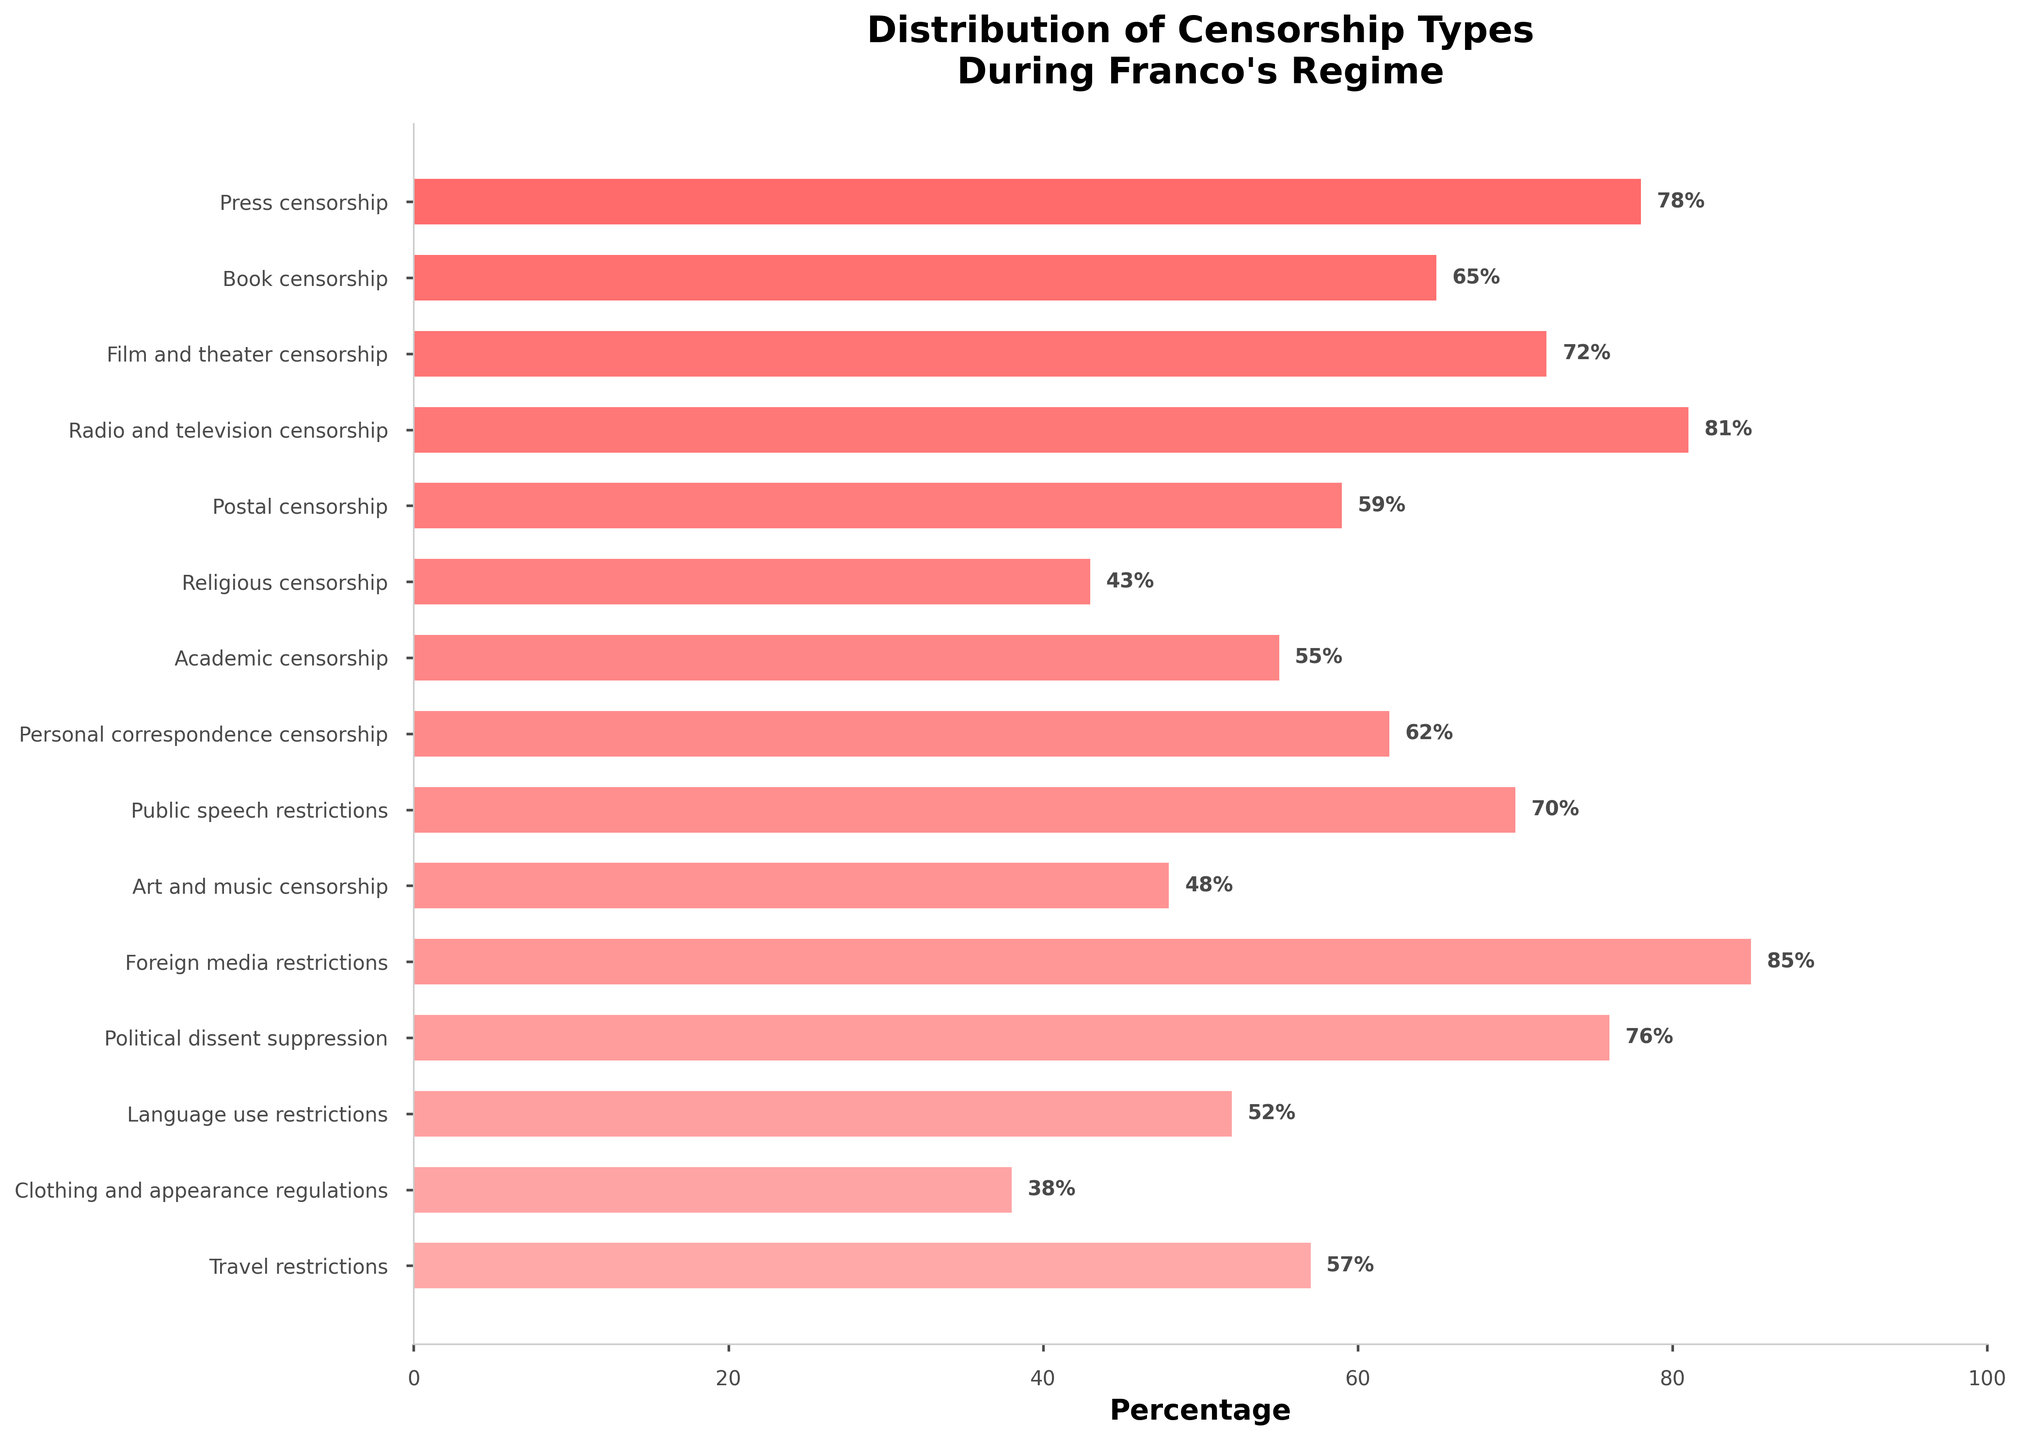Which type of censorship experienced by Spanish citizens during Franco's regime had the highest percentage? The highest percentage corresponds to foreign media restrictions, which had 85%.
Answer: Foreign media restrictions Which type of censorship had the smallest percentage? Clothing and appearance regulations had the lowest percentage at 38%.
Answer: Clothing and appearance regulations How does the percentage of press censorship compare to that of book censorship? Press censorship is 78%, which is higher than book censorship's 65%.
Answer: Press censorship is higher What is the average percentage of censorship across all categories? To calculate the average percentage, sum all percentage values (78, 65, 72, 81, 59, 43, 55, 62, 70, 48, 85, 76, 52, 38, 57), and then divide by the number of categories (15). Average = (78+65+72+81+59+43+55+62+70+48+85+76+52+38+57)/15 = 63.
Answer: 63 Which types of censorship have a percentage higher than 70%? The types of censorship with percentages higher than 70% are press censorship (78%), film and theater censorship (72%), radio and television censorship (81%), foreign media restrictions (85%), and political dissent suppression (76%).
Answer: Press censorship, film and theater censorship, radio and television censorship, foreign media restrictions, political dissent suppression Is personal correspondence censorship more common than academic censorship? Personal correspondence censorship is at 62%, which is higher than academic censorship's 55%.
Answer: Yes How does religious censorship's percentage compare to art and music censorship? Religious censorship is 43%, which is lower than art and music censorship's 48%.
Answer: Religious censorship is lower What is the difference in percentage between book censorship and public speech restrictions? The percentage difference between book censorship (65%) and public speech restrictions (70%) is 70 - 65 = 5%.
Answer: 5% Which category is almost as common as film and theater censorship but slightly less than political dissent suppression in percentage? Public speech restrictions are at 70%, which is just slightly less than political dissent suppression at 76% and almost as common as film and theater censorship at 72%.
Answer: Public speech restrictions Between radio and television censorship and travel restrictions, which one had a higher percentage? Radio and television censorship is higher at 81% compared to travel restrictions at 57%.
Answer: Radio and television censorship 